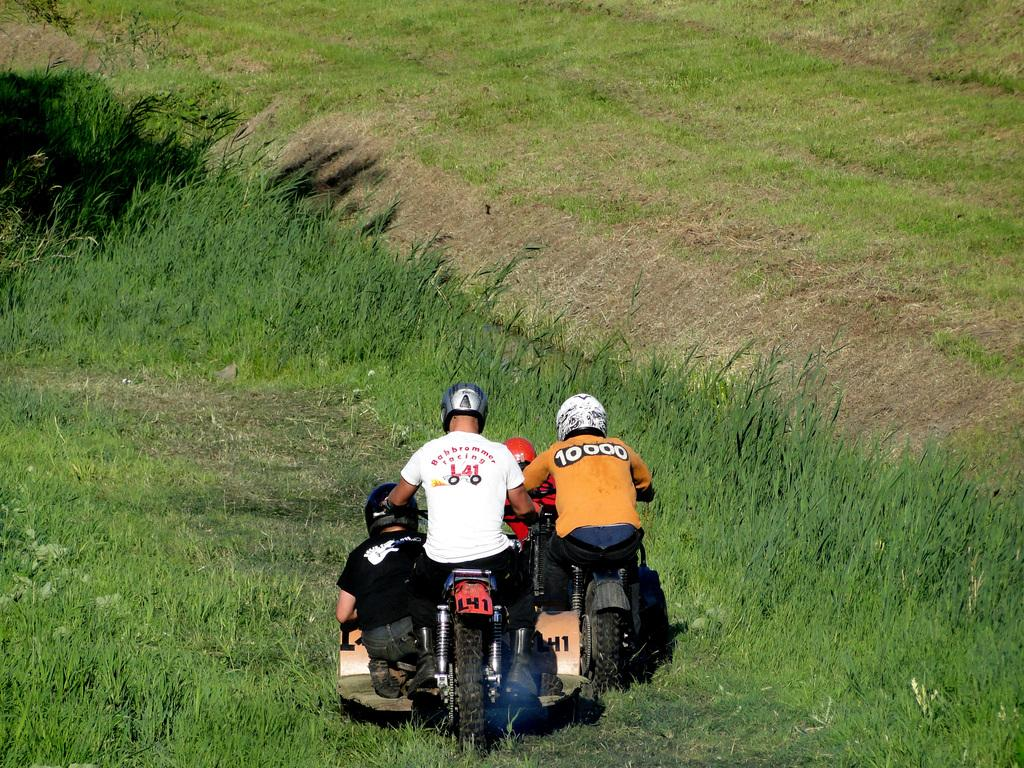What are the two persons in the image doing? The two persons in the image are riding bikes. Is there anyone else with them in the image? Yes, there is another person sitting beside them. What is the landscape like in the image? There is grass in front of them. What type of nose can be seen on the person sitting beside them? There is no information about the person's nose in the image, as the focus is on their activity and the presence of the other two persons. 